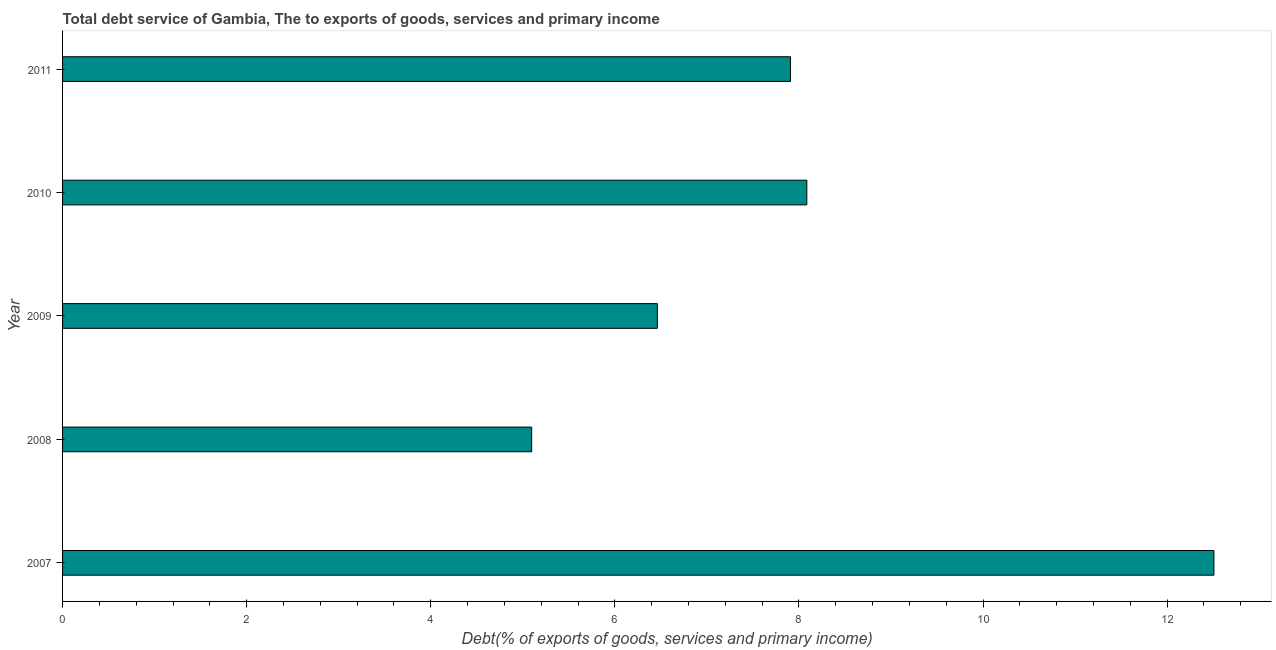What is the title of the graph?
Provide a succinct answer. Total debt service of Gambia, The to exports of goods, services and primary income. What is the label or title of the X-axis?
Ensure brevity in your answer.  Debt(% of exports of goods, services and primary income). What is the total debt service in 2009?
Your response must be concise. 6.46. Across all years, what is the maximum total debt service?
Provide a short and direct response. 12.51. Across all years, what is the minimum total debt service?
Your answer should be very brief. 5.1. What is the sum of the total debt service?
Your response must be concise. 40.06. What is the difference between the total debt service in 2009 and 2011?
Your response must be concise. -1.45. What is the average total debt service per year?
Provide a succinct answer. 8.01. What is the median total debt service?
Offer a very short reply. 7.91. In how many years, is the total debt service greater than 6.4 %?
Your answer should be very brief. 4. Do a majority of the years between 2009 and 2010 (inclusive) have total debt service greater than 3.2 %?
Make the answer very short. Yes. What is the ratio of the total debt service in 2008 to that in 2011?
Ensure brevity in your answer.  0.64. What is the difference between the highest and the second highest total debt service?
Your answer should be very brief. 4.42. What is the difference between the highest and the lowest total debt service?
Offer a terse response. 7.41. In how many years, is the total debt service greater than the average total debt service taken over all years?
Your answer should be very brief. 2. How many years are there in the graph?
Give a very brief answer. 5. Are the values on the major ticks of X-axis written in scientific E-notation?
Your answer should be very brief. No. What is the Debt(% of exports of goods, services and primary income) of 2007?
Your response must be concise. 12.51. What is the Debt(% of exports of goods, services and primary income) in 2008?
Keep it short and to the point. 5.1. What is the Debt(% of exports of goods, services and primary income) in 2009?
Give a very brief answer. 6.46. What is the Debt(% of exports of goods, services and primary income) of 2010?
Your response must be concise. 8.09. What is the Debt(% of exports of goods, services and primary income) of 2011?
Offer a terse response. 7.91. What is the difference between the Debt(% of exports of goods, services and primary income) in 2007 and 2008?
Keep it short and to the point. 7.41. What is the difference between the Debt(% of exports of goods, services and primary income) in 2007 and 2009?
Your response must be concise. 6.05. What is the difference between the Debt(% of exports of goods, services and primary income) in 2007 and 2010?
Give a very brief answer. 4.42. What is the difference between the Debt(% of exports of goods, services and primary income) in 2007 and 2011?
Offer a terse response. 4.6. What is the difference between the Debt(% of exports of goods, services and primary income) in 2008 and 2009?
Make the answer very short. -1.37. What is the difference between the Debt(% of exports of goods, services and primary income) in 2008 and 2010?
Your answer should be compact. -2.99. What is the difference between the Debt(% of exports of goods, services and primary income) in 2008 and 2011?
Give a very brief answer. -2.81. What is the difference between the Debt(% of exports of goods, services and primary income) in 2009 and 2010?
Ensure brevity in your answer.  -1.62. What is the difference between the Debt(% of exports of goods, services and primary income) in 2009 and 2011?
Offer a very short reply. -1.45. What is the difference between the Debt(% of exports of goods, services and primary income) in 2010 and 2011?
Offer a terse response. 0.18. What is the ratio of the Debt(% of exports of goods, services and primary income) in 2007 to that in 2008?
Your response must be concise. 2.45. What is the ratio of the Debt(% of exports of goods, services and primary income) in 2007 to that in 2009?
Ensure brevity in your answer.  1.94. What is the ratio of the Debt(% of exports of goods, services and primary income) in 2007 to that in 2010?
Your answer should be very brief. 1.55. What is the ratio of the Debt(% of exports of goods, services and primary income) in 2007 to that in 2011?
Provide a short and direct response. 1.58. What is the ratio of the Debt(% of exports of goods, services and primary income) in 2008 to that in 2009?
Your response must be concise. 0.79. What is the ratio of the Debt(% of exports of goods, services and primary income) in 2008 to that in 2010?
Give a very brief answer. 0.63. What is the ratio of the Debt(% of exports of goods, services and primary income) in 2008 to that in 2011?
Your answer should be compact. 0.64. What is the ratio of the Debt(% of exports of goods, services and primary income) in 2009 to that in 2010?
Your answer should be compact. 0.8. What is the ratio of the Debt(% of exports of goods, services and primary income) in 2009 to that in 2011?
Provide a succinct answer. 0.82. 